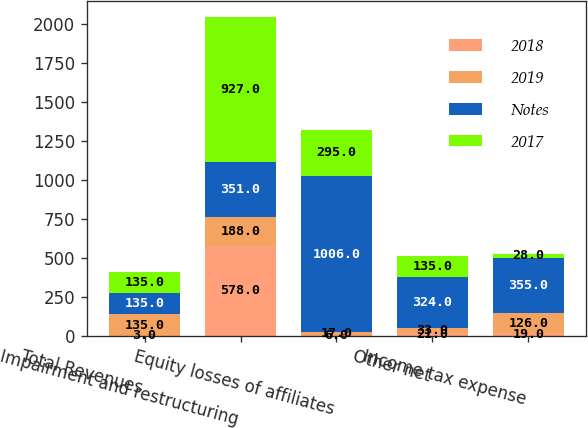Convert chart. <chart><loc_0><loc_0><loc_500><loc_500><stacked_bar_chart><ecel><fcel>Total Revenues<fcel>Impairment and restructuring<fcel>Equity losses of affiliates<fcel>Other net<fcel>Income tax expense<nl><fcel>2018<fcel>3<fcel>578<fcel>6<fcel>21<fcel>19<nl><fcel>2019<fcel>135<fcel>188<fcel>17<fcel>33<fcel>126<nl><fcel>Notes<fcel>135<fcel>351<fcel>1006<fcel>324<fcel>355<nl><fcel>2017<fcel>135<fcel>927<fcel>295<fcel>135<fcel>28<nl></chart> 